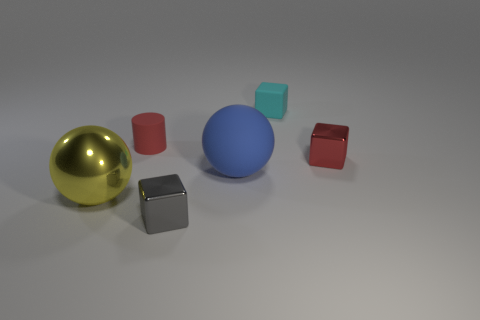Is the size of the red rubber object the same as the blue matte thing? no 